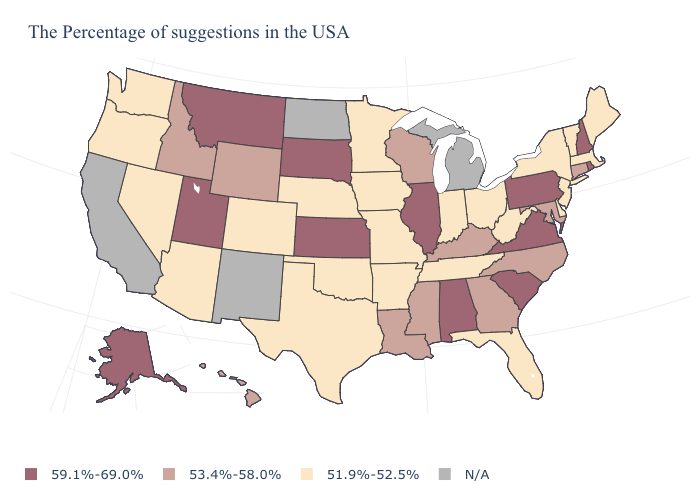Which states have the highest value in the USA?
Quick response, please. Rhode Island, New Hampshire, Pennsylvania, Virginia, South Carolina, Alabama, Illinois, Kansas, South Dakota, Utah, Montana, Alaska. Among the states that border West Virginia , which have the lowest value?
Write a very short answer. Ohio. Name the states that have a value in the range 51.9%-52.5%?
Be succinct. Maine, Massachusetts, Vermont, New York, New Jersey, Delaware, West Virginia, Ohio, Florida, Indiana, Tennessee, Missouri, Arkansas, Minnesota, Iowa, Nebraska, Oklahoma, Texas, Colorado, Arizona, Nevada, Washington, Oregon. Which states have the lowest value in the West?
Answer briefly. Colorado, Arizona, Nevada, Washington, Oregon. Name the states that have a value in the range 51.9%-52.5%?
Concise answer only. Maine, Massachusetts, Vermont, New York, New Jersey, Delaware, West Virginia, Ohio, Florida, Indiana, Tennessee, Missouri, Arkansas, Minnesota, Iowa, Nebraska, Oklahoma, Texas, Colorado, Arizona, Nevada, Washington, Oregon. What is the value of Hawaii?
Short answer required. 53.4%-58.0%. Does Missouri have the highest value in the USA?
Short answer required. No. What is the value of Rhode Island?
Short answer required. 59.1%-69.0%. Name the states that have a value in the range N/A?
Be succinct. Michigan, North Dakota, New Mexico, California. What is the lowest value in states that border Florida?
Short answer required. 53.4%-58.0%. What is the value of Pennsylvania?
Write a very short answer. 59.1%-69.0%. Does Montana have the highest value in the West?
Be succinct. Yes. What is the highest value in states that border Oklahoma?
Write a very short answer. 59.1%-69.0%. What is the value of Idaho?
Keep it brief. 53.4%-58.0%. What is the highest value in states that border Indiana?
Quick response, please. 59.1%-69.0%. 